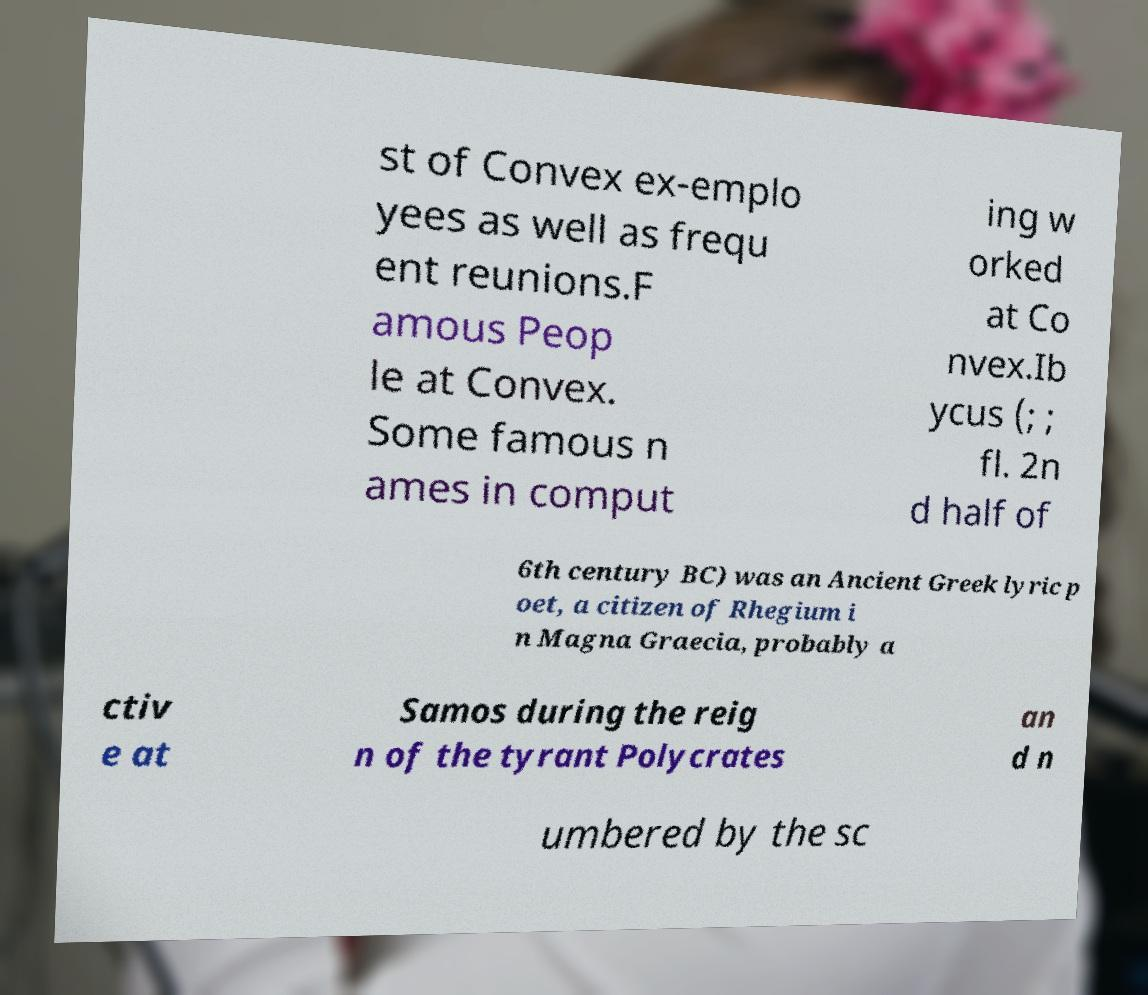Could you assist in decoding the text presented in this image and type it out clearly? st of Convex ex-emplo yees as well as frequ ent reunions.F amous Peop le at Convex. Some famous n ames in comput ing w orked at Co nvex.Ib ycus (; ; fl. 2n d half of 6th century BC) was an Ancient Greek lyric p oet, a citizen of Rhegium i n Magna Graecia, probably a ctiv e at Samos during the reig n of the tyrant Polycrates an d n umbered by the sc 